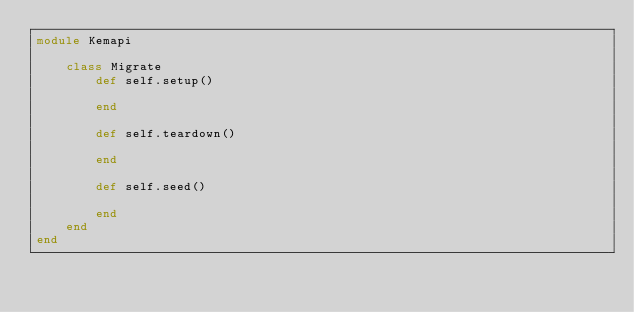Convert code to text. <code><loc_0><loc_0><loc_500><loc_500><_Crystal_>module Kemapi

    class Migrate
        def self.setup()

        end

        def self.teardown()

        end

        def self.seed()

        end
    end
end</code> 